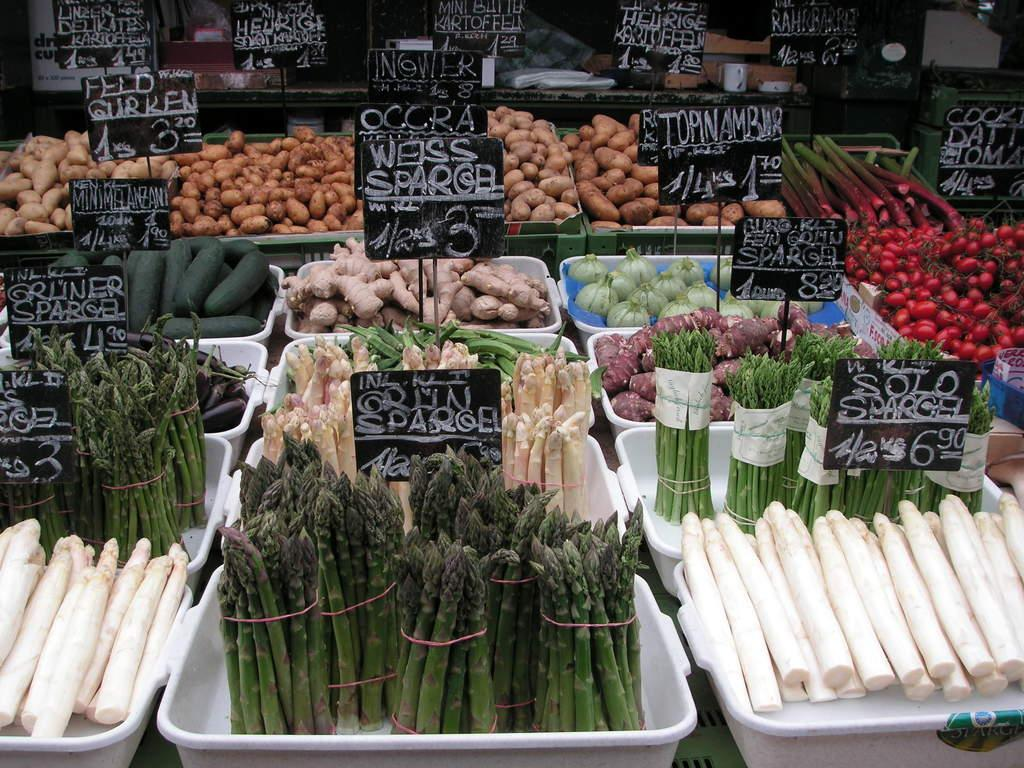What type of food items can be seen in the image? There are vegetables in the image. What are the boards used for in the image? The boards are present in the image, but their purpose is not specified. What are the plastic trays used for in the image? The plastic trays are present in the image, but their purpose is not specified. Can you describe the objects at the top of the image? At the top of the image, there are boards, a cup, papers, and other objects. What color is the paint on the shelf in the image? There is no shelf or paint present in the image. 